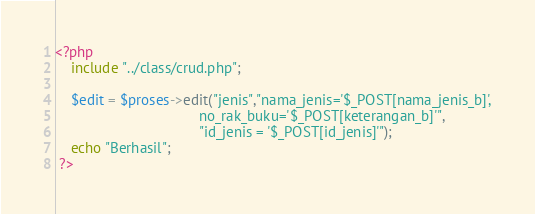Convert code to text. <code><loc_0><loc_0><loc_500><loc_500><_PHP_><?php 
	include "../class/crud.php";

	$edit = $proses->edit("jenis","nama_jenis='$_POST[nama_jenis_b]',
									no_rak_buku='$_POST[keterangan_b]'",
									"id_jenis = '$_POST[id_jenis]'");
	echo "Berhasil";
 ?></code> 